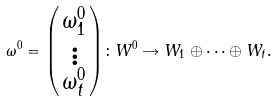<formula> <loc_0><loc_0><loc_500><loc_500>\omega ^ { 0 } = \begin{psmallmatrix} \omega ^ { 0 } _ { 1 } \\ \vdots \\ \omega ^ { 0 } _ { t } \end{psmallmatrix} \colon W ^ { 0 } \rightarrow W _ { 1 } \oplus \cdots \oplus W _ { t } .</formula> 